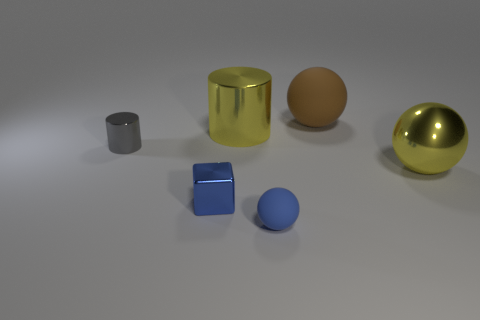The cylinder that is on the right side of the tiny thing that is behind the yellow thing that is to the right of the blue sphere is made of what material?
Keep it short and to the point. Metal. What number of rubber things are small gray cylinders or brown things?
Offer a very short reply. 1. Do the large metallic cylinder and the large matte sphere have the same color?
Provide a succinct answer. No. Are there any other things that have the same material as the small ball?
Provide a short and direct response. Yes. How many objects are red objects or shiny things that are left of the tiny blue metallic object?
Your answer should be very brief. 1. Does the matte ball that is in front of the gray cylinder have the same size as the brown ball?
Your answer should be compact. No. How many other things are there of the same shape as the blue metal object?
Offer a terse response. 0. What number of blue things are either matte spheres or big things?
Provide a succinct answer. 1. Is the color of the rubber ball that is on the right side of the blue matte ball the same as the shiny block?
Give a very brief answer. No. There is a big thing that is the same material as the small ball; what is its shape?
Keep it short and to the point. Sphere. 